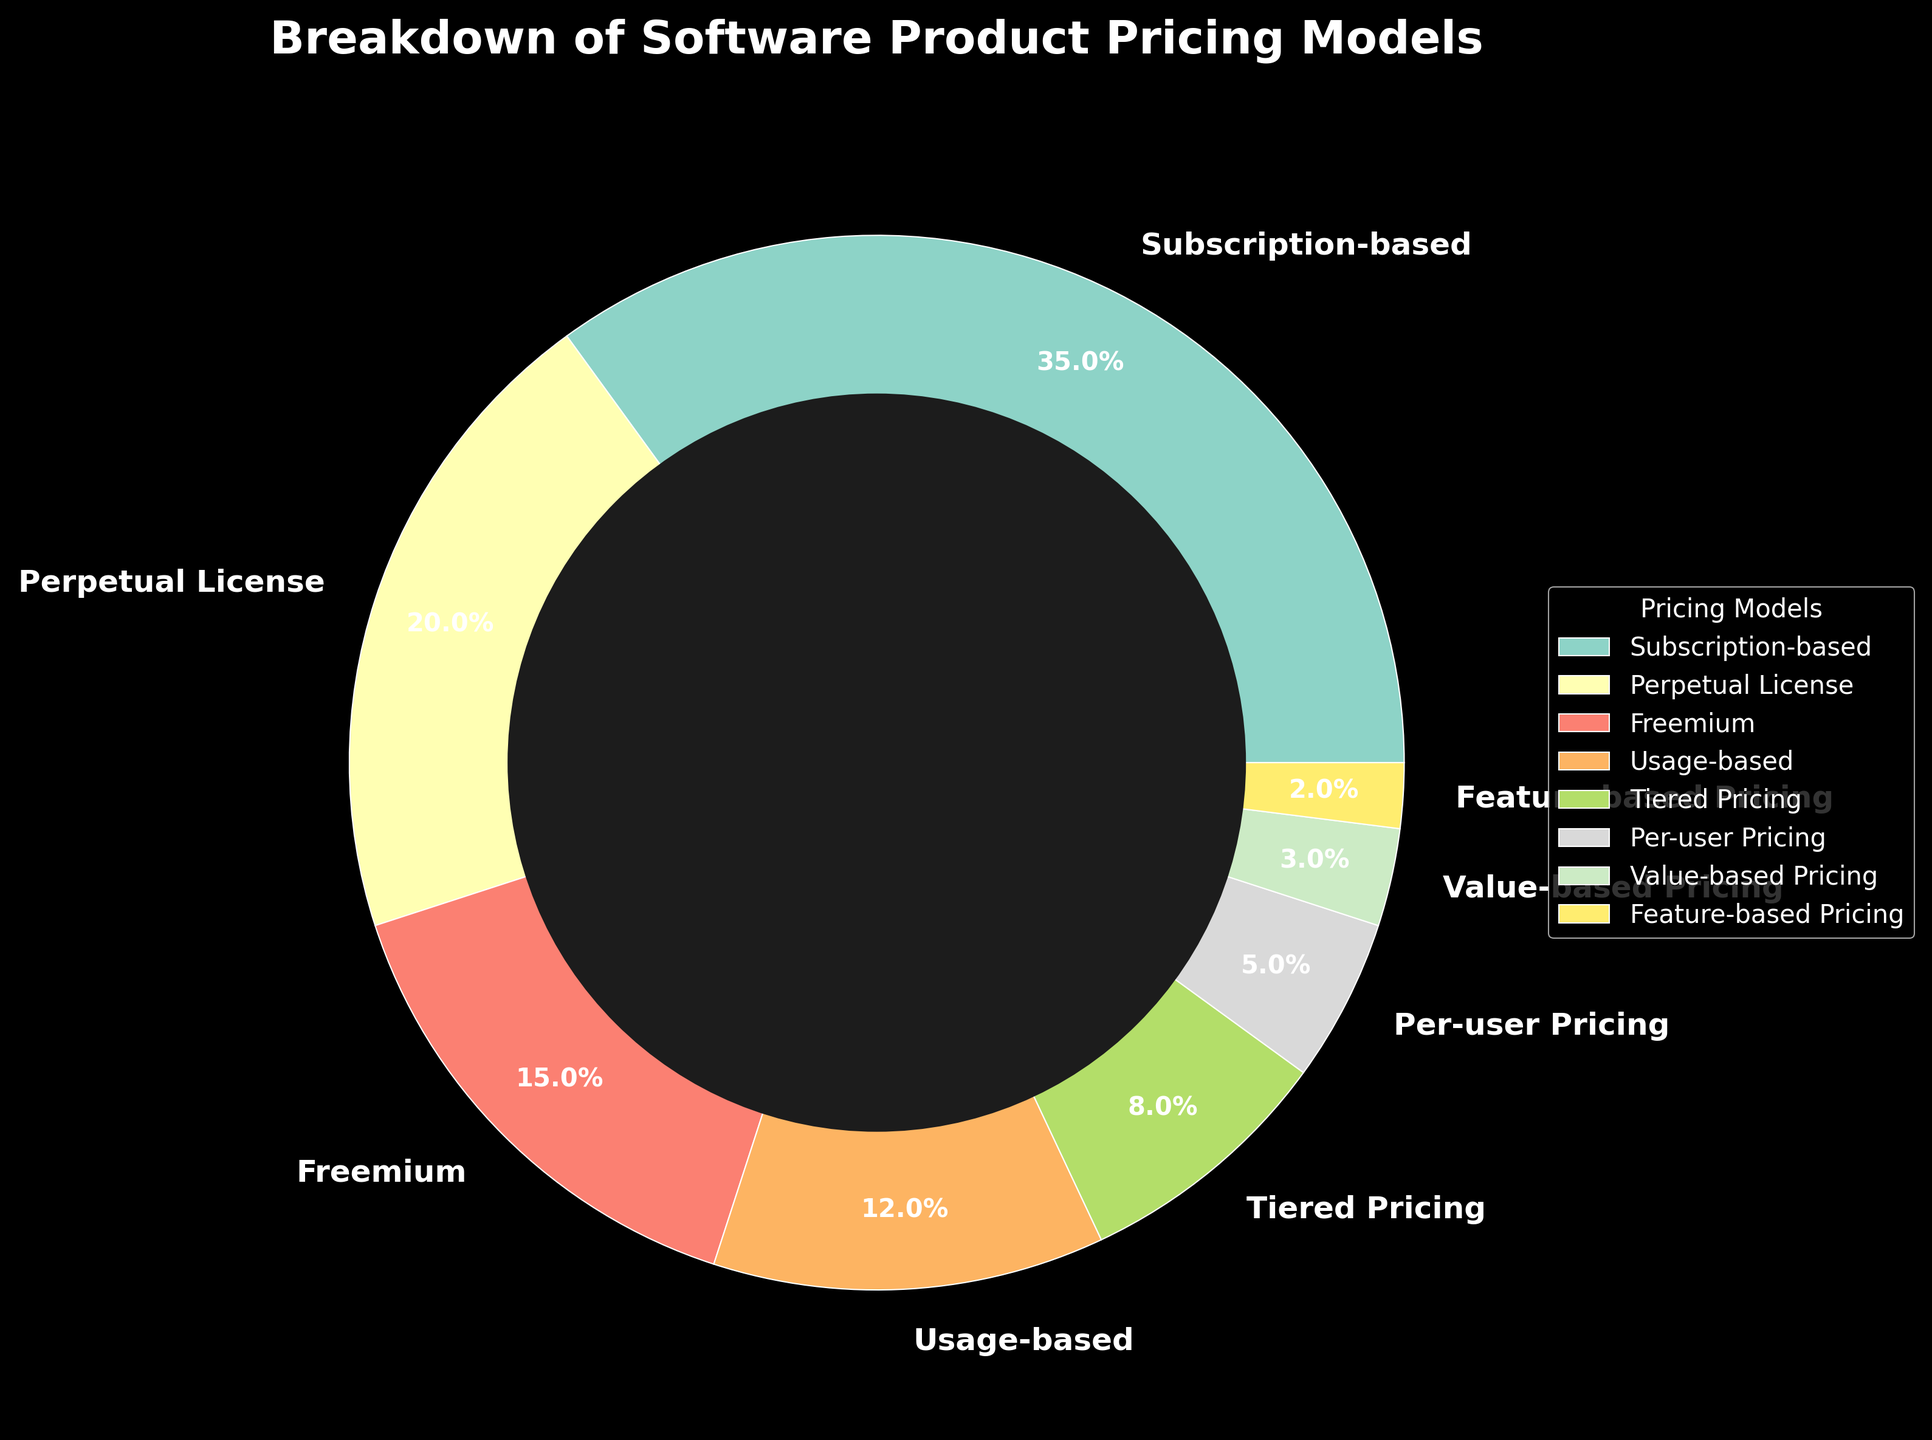What is the most common pricing model for software products according to the chart? The pie chart shows that the biggest section is labeled "Subscription-based" which occupies the largest area of the chart.
Answer: Subscription-based Which pricing model represents the smallest percentage? The pie chart indicates that the smallest slice is labeled "Feature-based Pricing," showing it has the least representation.
Answer: Feature-based Pricing What is the combined percentage of Subscription-based and Perpetual License models? The pie chart details 35% for Subscription-based and 20% for Perpetual License. Adding these gives 35 + 20 = 55%.
Answer: 55% Which pricing models combined make up less than 10% each? Observing the pie chart, Tiered Pricing at 8%, Per-user Pricing at 5%, Value-based Pricing at 3%, and Feature-based Pricing at 2% all represent less than 10% each.
Answer: Tiered Pricing, Per-user Pricing, Value-based Pricing, Feature-based Pricing Is the percentage for Freemium pricing greater than that for Tiered Pricing? The pie chart illustrates that Freemium is 15%, whereas Tiered Pricing is 8%. Thus, Freemium is indeed greater.
Answer: Yes Which pricing model(s) together equal the percentage of the Subscription-based model? Subscription-based is 35%. The total of Perpetual License (20%), Usage-based (12%), and Feature-based Pricing (2%) is 20 + 12 + 2 = 34%. Adding Value-based Pricing (3%) would surpass 35%, hence no exact match. However, close combinations could be identified for estimation.
Answer: No exact match What is the difference in percentage between Perpetual License and Usage-based pricing models? The pie chart indicates Perpetual License is 20% and Usage-based is 12%. Therefore, the difference is 20 - 12 = 8%.
Answer: 8% What proportion of the total percentage do the top three pricing models constitute? Subscription-based (35%), Perpetual License (20%), and Freemium (15%) sum up to 35 + 20 + 15 = 70%.
Answer: 70% Are there any pricing models that appear in similar-sized sections? Visually, Perpetual License (20%) and Freemium (15%) have similarly sized sections, appearing close in size compared to the other segments.
Answer: Perpetual License and Freemium What is the ratio between Subscription-based and Usage-based pricing models? The pie chart reveals Subscription-based is 35% while Usage-based is 12%. The ratio is 35:12, which simplifies approximately to 2.92:1.
Answer: Approximately 3:1 